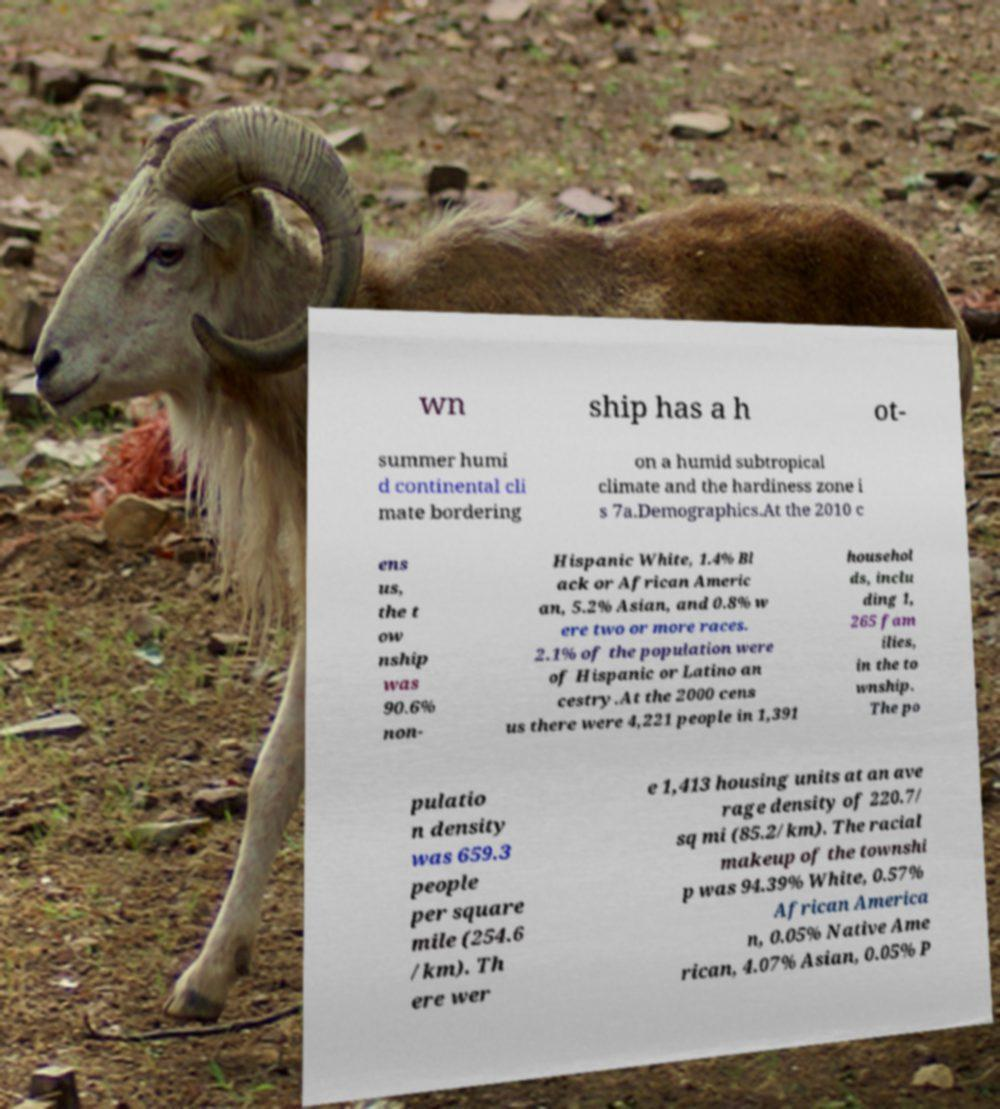There's text embedded in this image that I need extracted. Can you transcribe it verbatim? wn ship has a h ot- summer humi d continental cli mate bordering on a humid subtropical climate and the hardiness zone i s 7a.Demographics.At the 2010 c ens us, the t ow nship was 90.6% non- Hispanic White, 1.4% Bl ack or African Americ an, 5.2% Asian, and 0.8% w ere two or more races. 2.1% of the population were of Hispanic or Latino an cestry.At the 2000 cens us there were 4,221 people in 1,391 househol ds, inclu ding 1, 265 fam ilies, in the to wnship. The po pulatio n density was 659.3 people per square mile (254.6 /km). Th ere wer e 1,413 housing units at an ave rage density of 220.7/ sq mi (85.2/km). The racial makeup of the townshi p was 94.39% White, 0.57% African America n, 0.05% Native Ame rican, 4.07% Asian, 0.05% P 